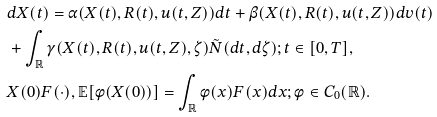Convert formula to latex. <formula><loc_0><loc_0><loc_500><loc_500>& d X ( t ) = \alpha ( X ( t ) , R ( t ) , u ( t , Z ) ) d t + \beta ( X ( t ) , R ( t ) , u ( t , Z ) ) d v ( t ) \\ & + \int _ { \mathbb { R } } \gamma ( X ( t ) , R ( t ) , u ( t , Z ) , \zeta ) \tilde { N } ( d t , d \zeta ) ; t \in [ 0 , T ] , \\ & X ( 0 ) F ( \cdot ) , \mathbb { E } [ \phi ( X ( 0 ) ) ] = \int _ { \mathbb { R } } \phi ( x ) F ( x ) d x ; \phi \in C _ { 0 } ( \mathbb { R } ) .</formula> 